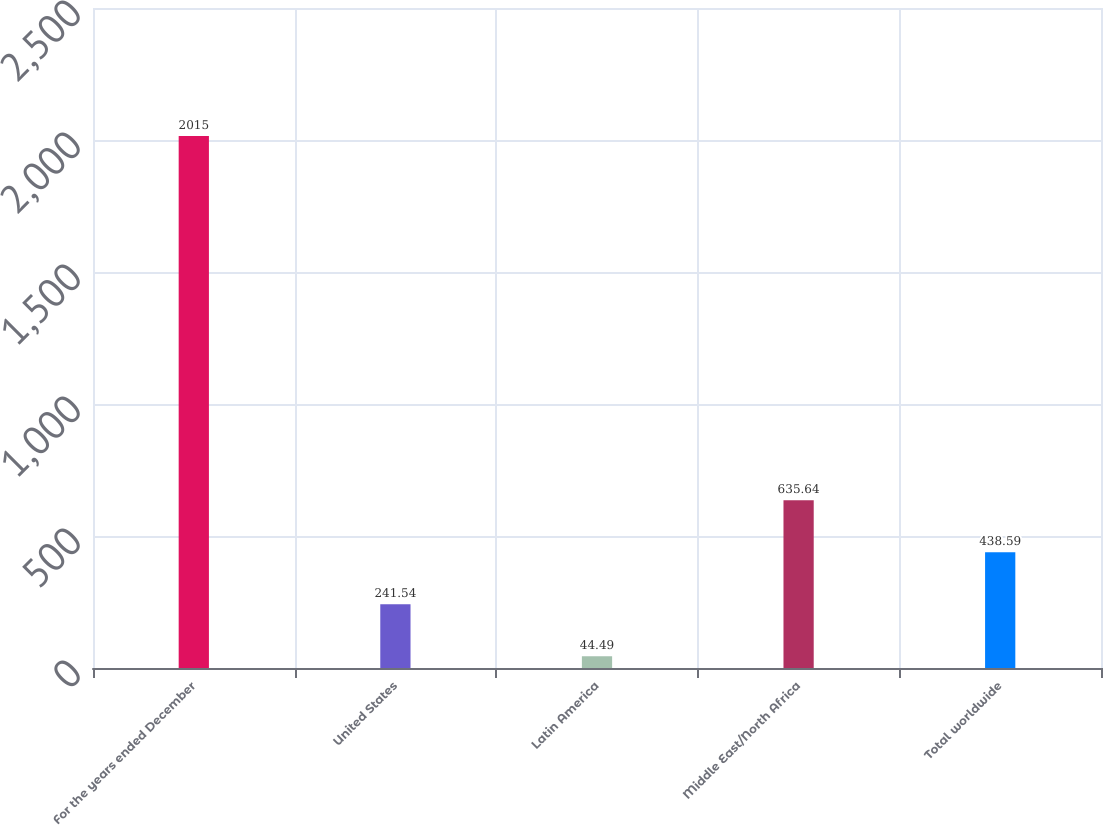Convert chart. <chart><loc_0><loc_0><loc_500><loc_500><bar_chart><fcel>For the years ended December<fcel>United States<fcel>Latin America<fcel>Middle East/North Africa<fcel>Total worldwide<nl><fcel>2015<fcel>241.54<fcel>44.49<fcel>635.64<fcel>438.59<nl></chart> 